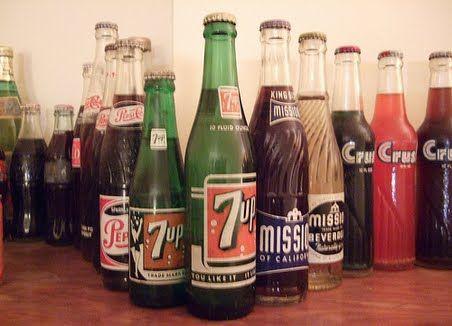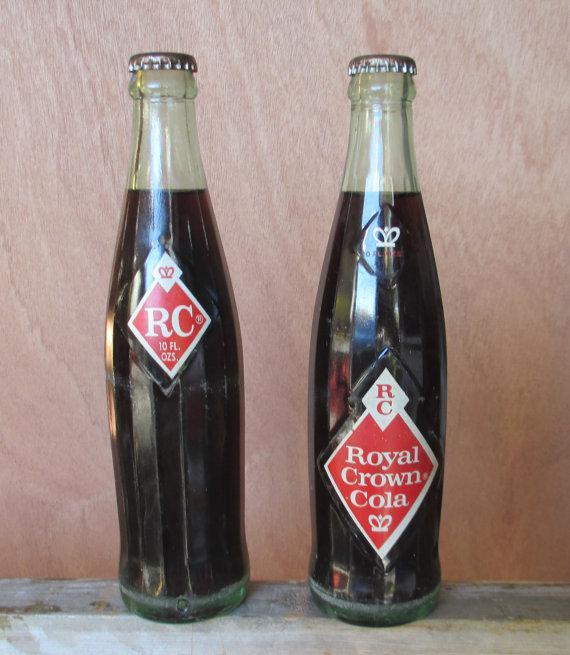The first image is the image on the left, the second image is the image on the right. Considering the images on both sides, is "All the bottles in these images are unopened and full of a beverage." valid? Answer yes or no. Yes. The first image is the image on the left, the second image is the image on the right. Evaluate the accuracy of this statement regarding the images: "There are empty bottles sitting on a shelf.". Is it true? Answer yes or no. No. 